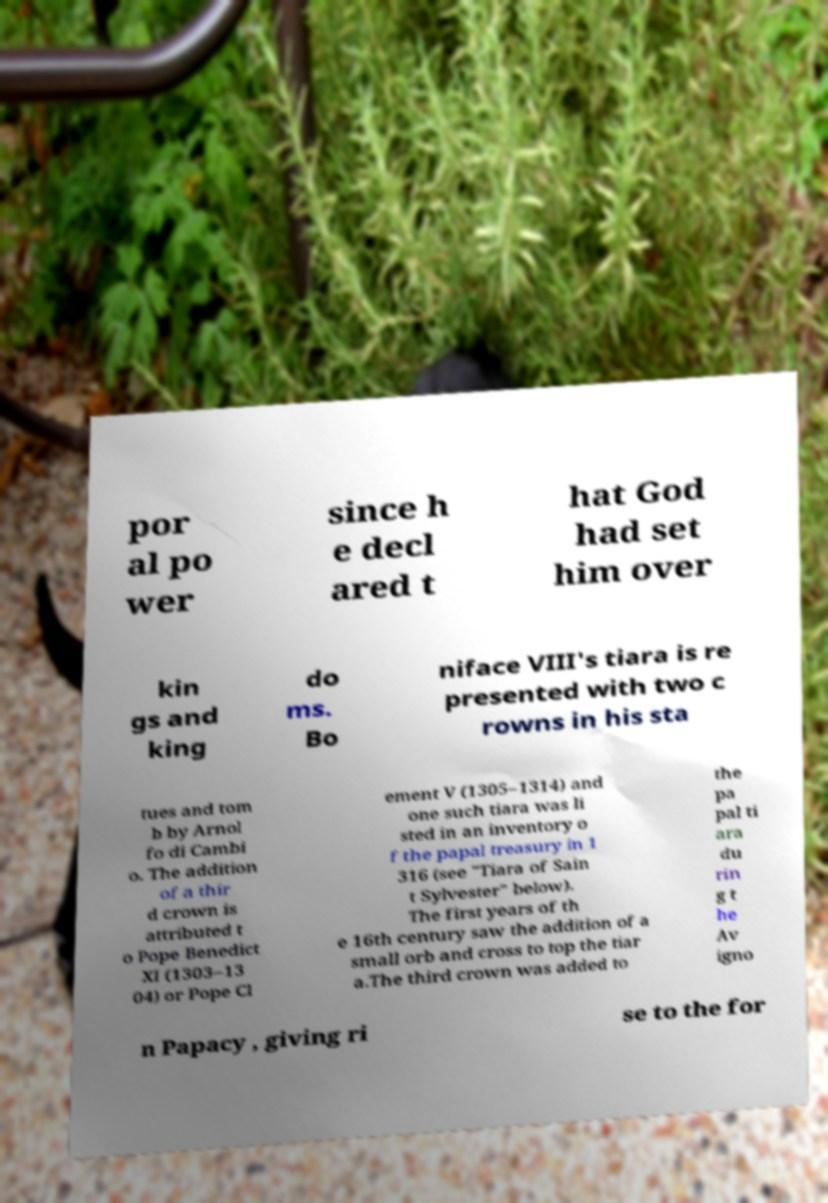For documentation purposes, I need the text within this image transcribed. Could you provide that? por al po wer since h e decl ared t hat God had set him over kin gs and king do ms. Bo niface VIII's tiara is re presented with two c rowns in his sta tues and tom b by Arnol fo di Cambi o. The addition of a thir d crown is attributed t o Pope Benedict XI (1303–13 04) or Pope Cl ement V (1305–1314) and one such tiara was li sted in an inventory o f the papal treasury in 1 316 (see "Tiara of Sain t Sylvester" below). The first years of th e 16th century saw the addition of a small orb and cross to top the tiar a.The third crown was added to the pa pal ti ara du rin g t he Av igno n Papacy , giving ri se to the for 